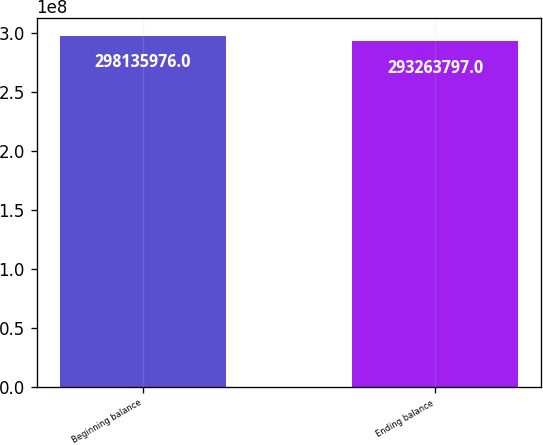Convert chart to OTSL. <chart><loc_0><loc_0><loc_500><loc_500><bar_chart><fcel>Beginning balance<fcel>Ending balance<nl><fcel>2.98136e+08<fcel>2.93264e+08<nl></chart> 